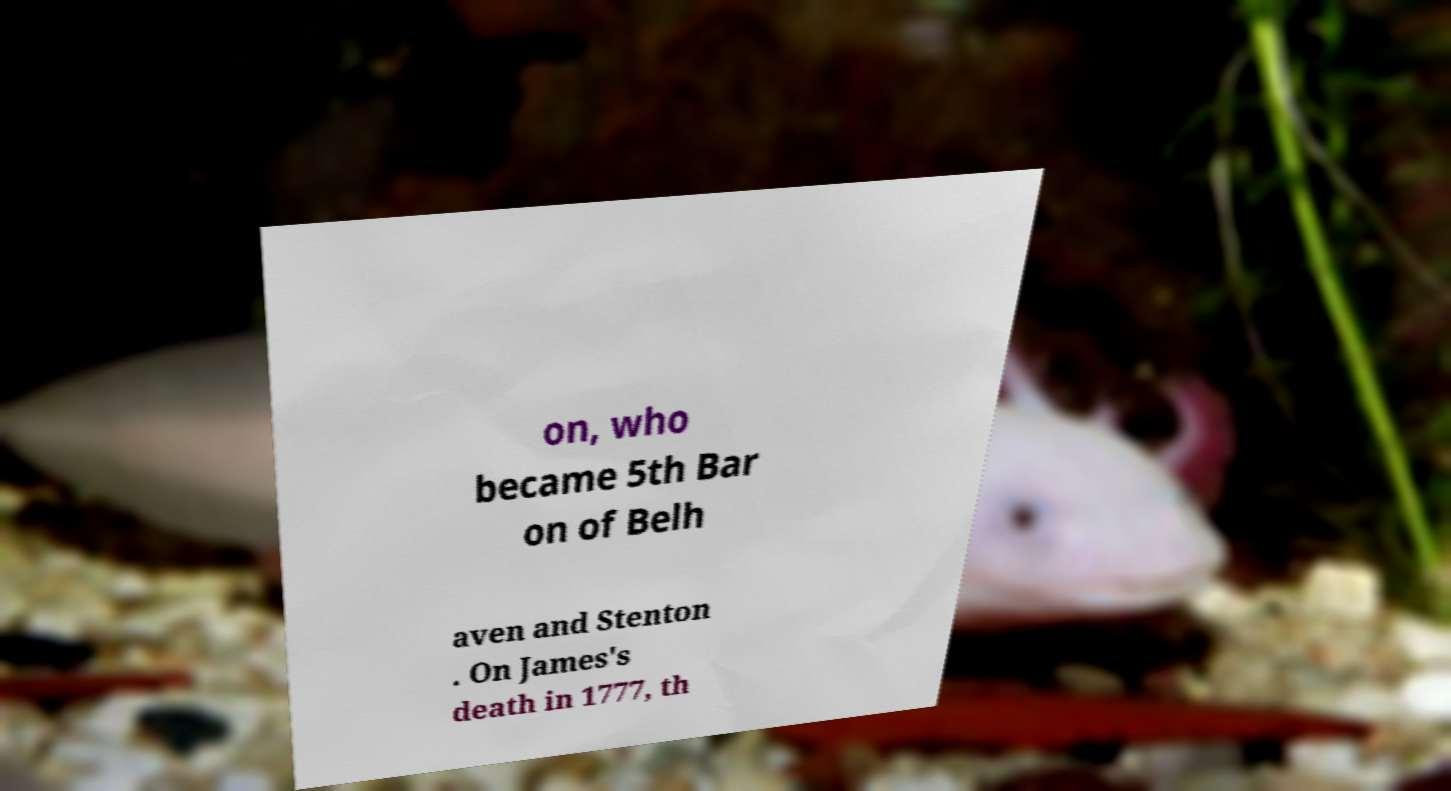There's text embedded in this image that I need extracted. Can you transcribe it verbatim? on, who became 5th Bar on of Belh aven and Stenton . On James's death in 1777, th 